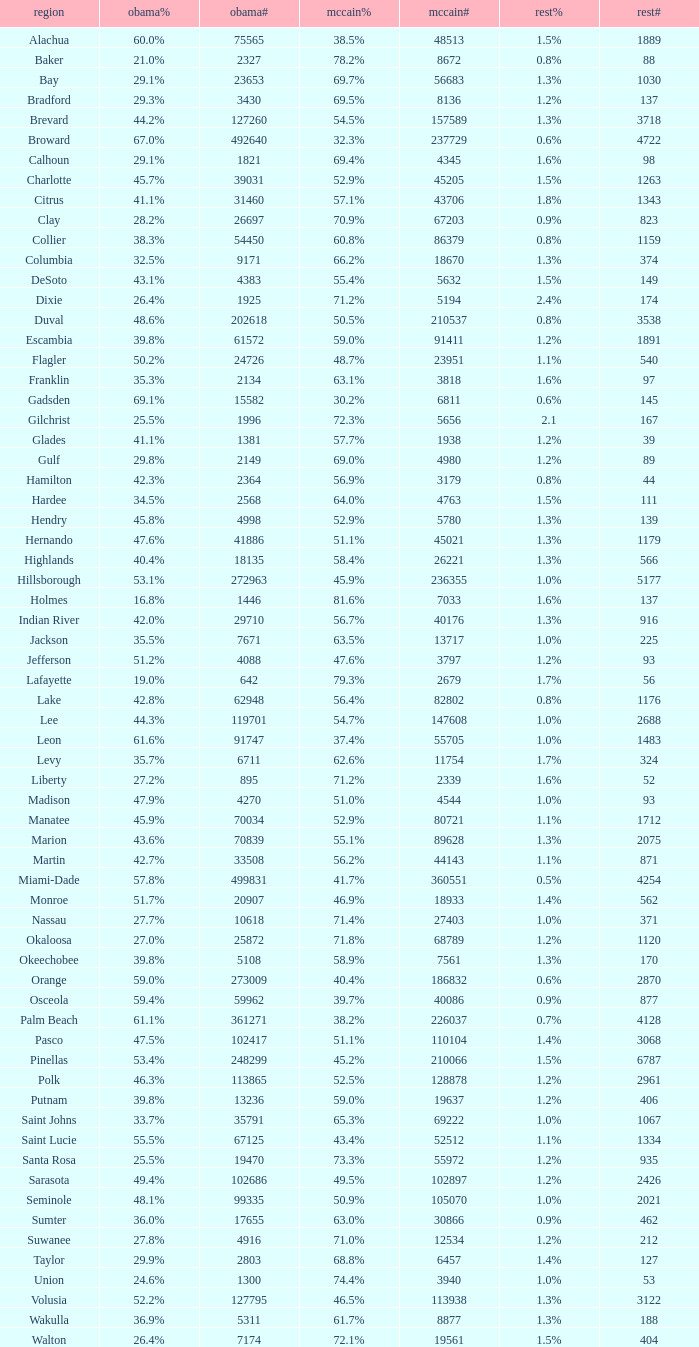What was the number of others votes in Columbia county? 374.0. 